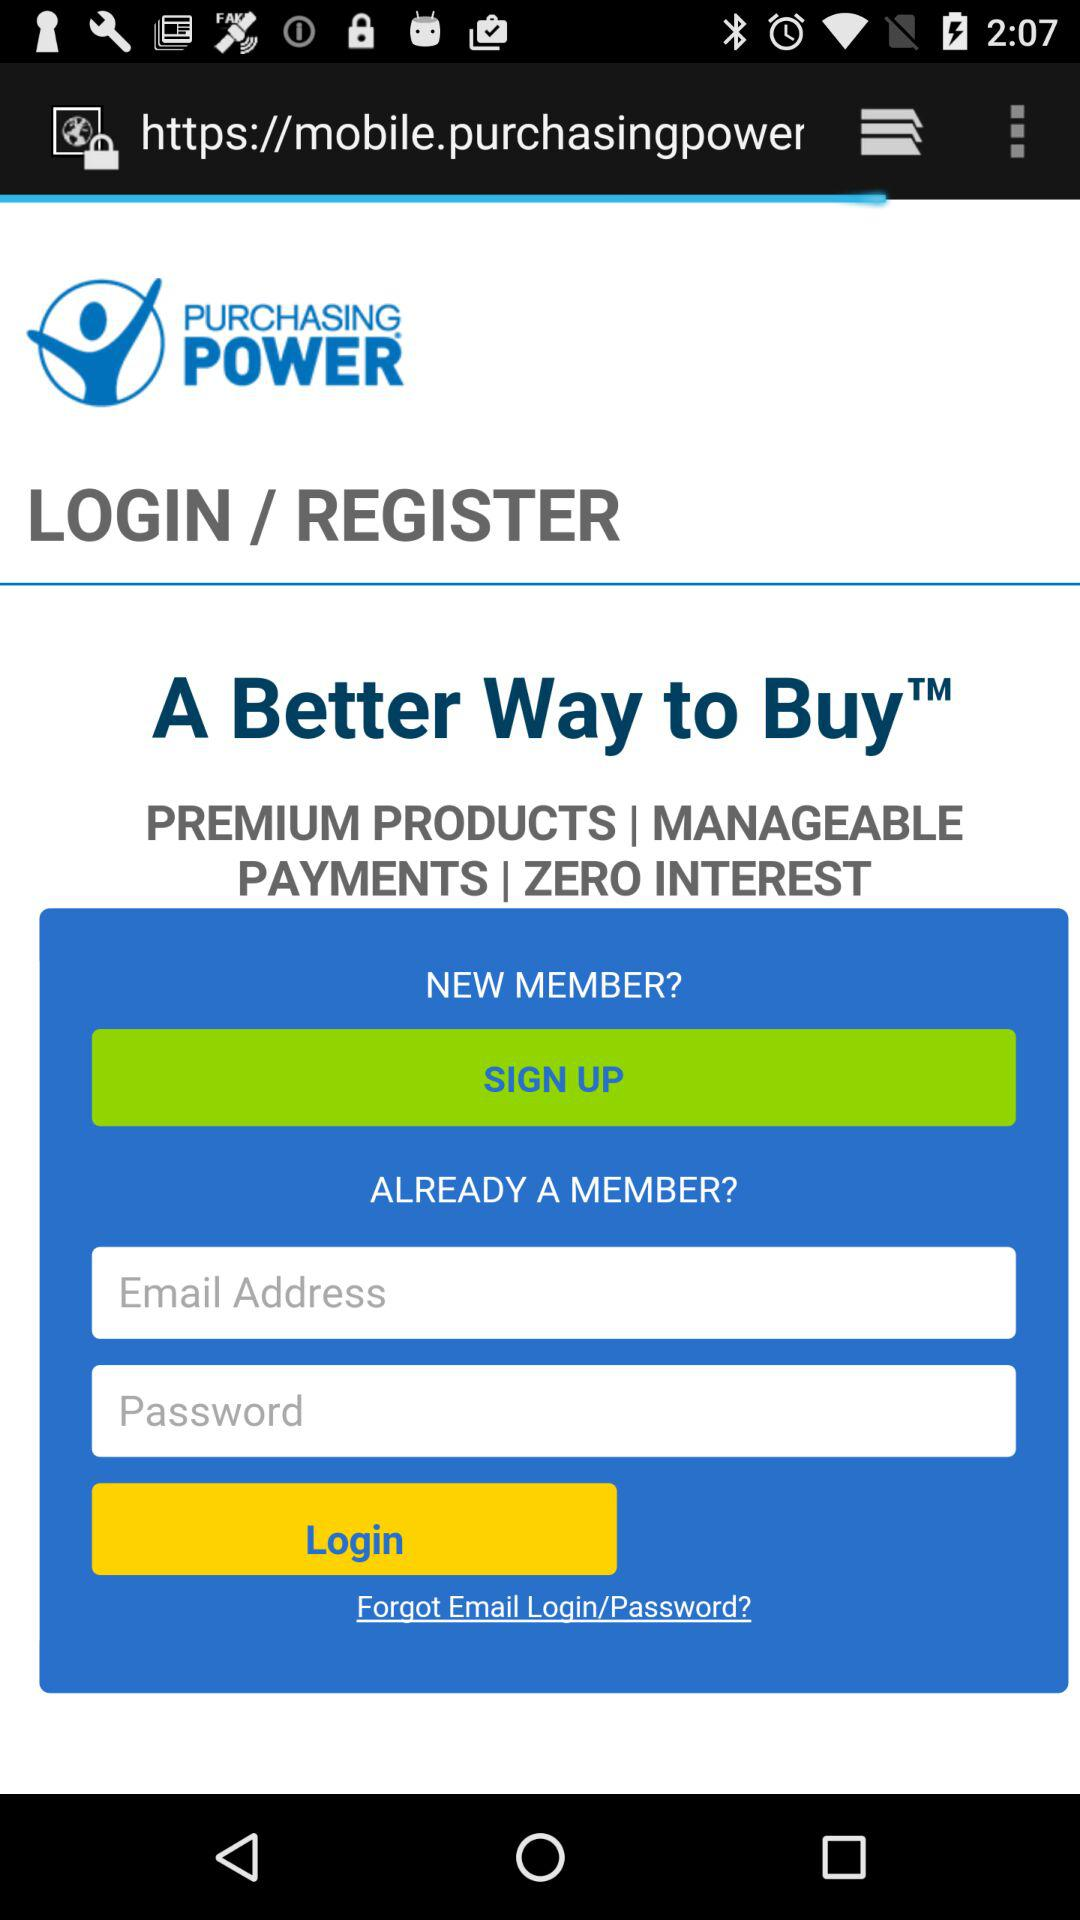What is the name of the application? The application name is Purchasing Power. 